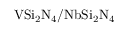<formula> <loc_0><loc_0><loc_500><loc_500>V S i _ { 2 } N _ { 4 } / N b S i _ { 2 } N _ { 4 }</formula> 